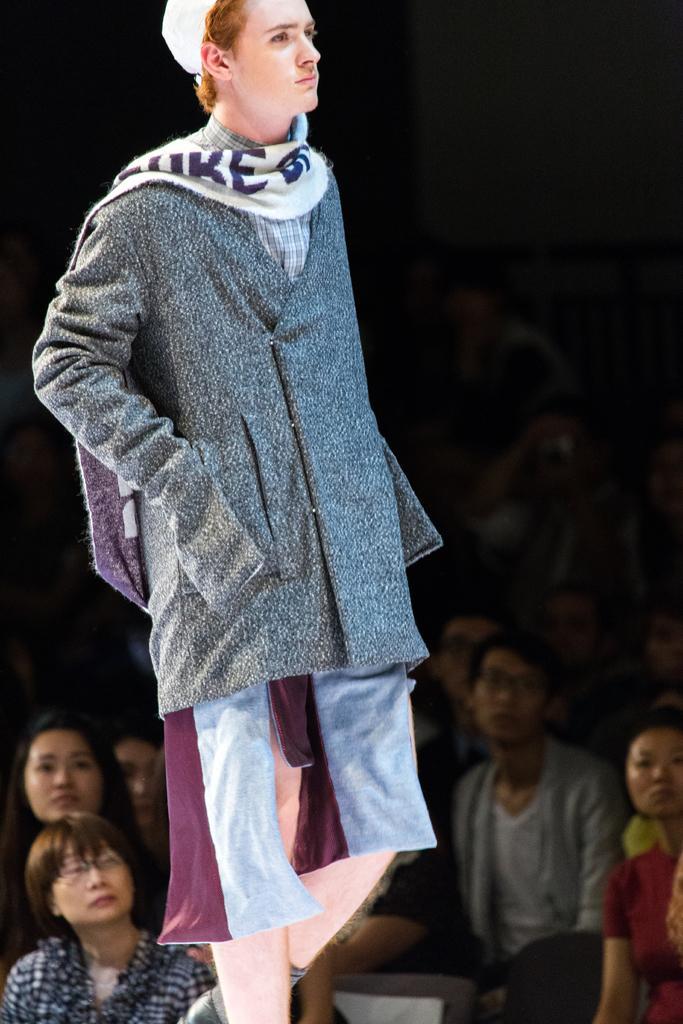Could you give a brief overview of what you see in this image? In the image in the center we can see one person is standing and he is in different costume. In the background we can see a few people were sitting. 